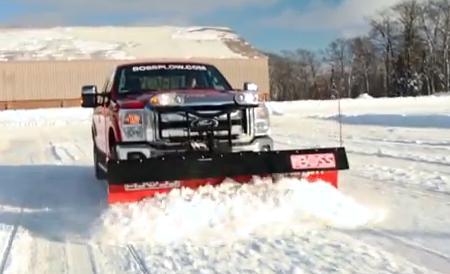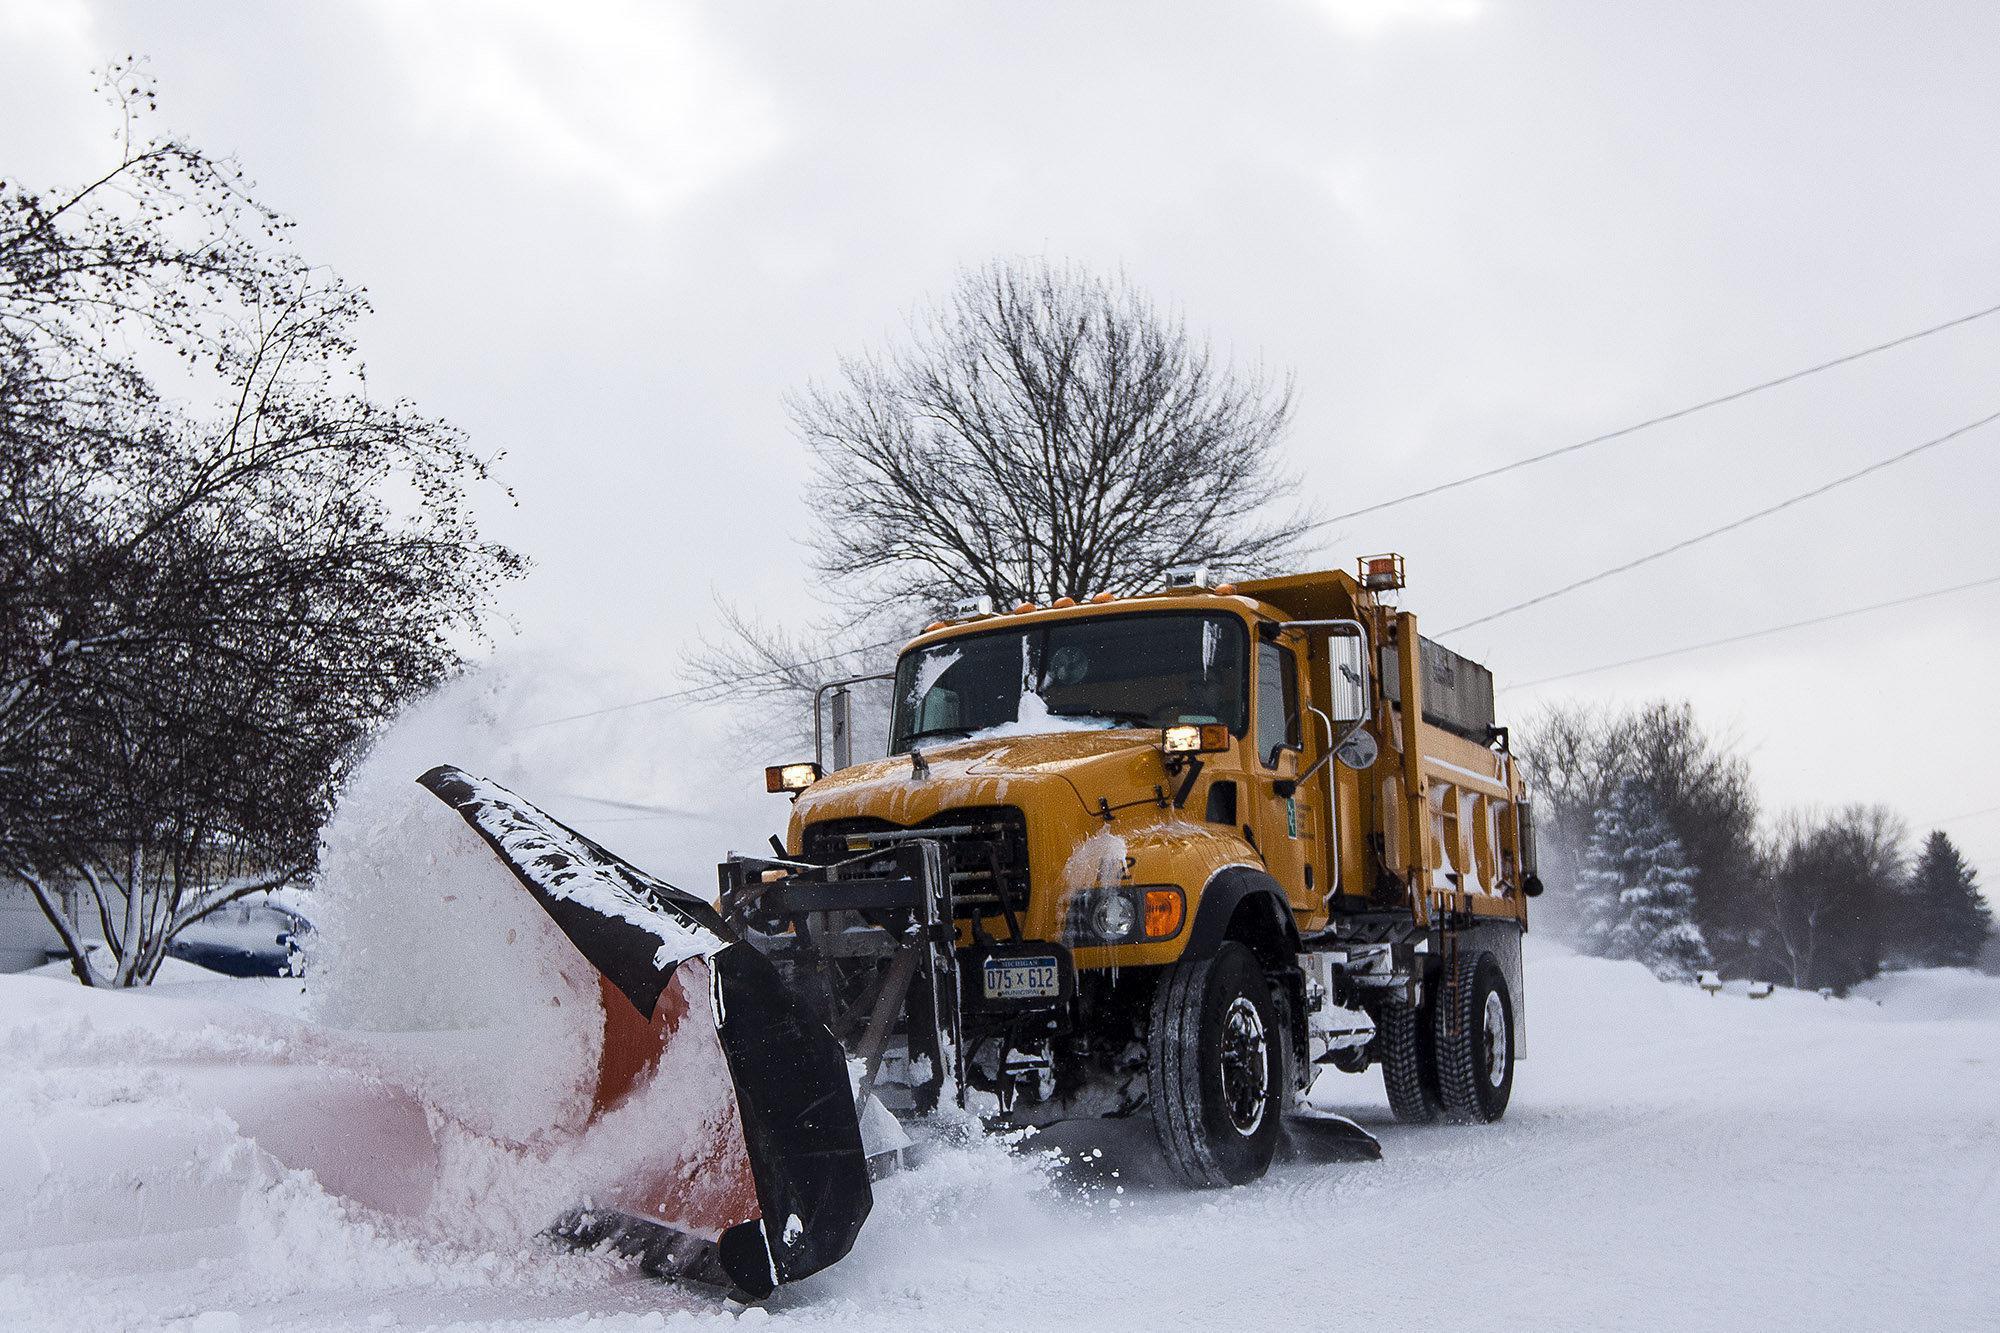The first image is the image on the left, the second image is the image on the right. For the images shown, is this caption "The left image contains at least two snow plows." true? Answer yes or no. No. The first image is the image on the left, the second image is the image on the right. Evaluate the accuracy of this statement regarding the images: "An image shows at least one yellow truck clearing snow with a plow.". Is it true? Answer yes or no. Yes. 